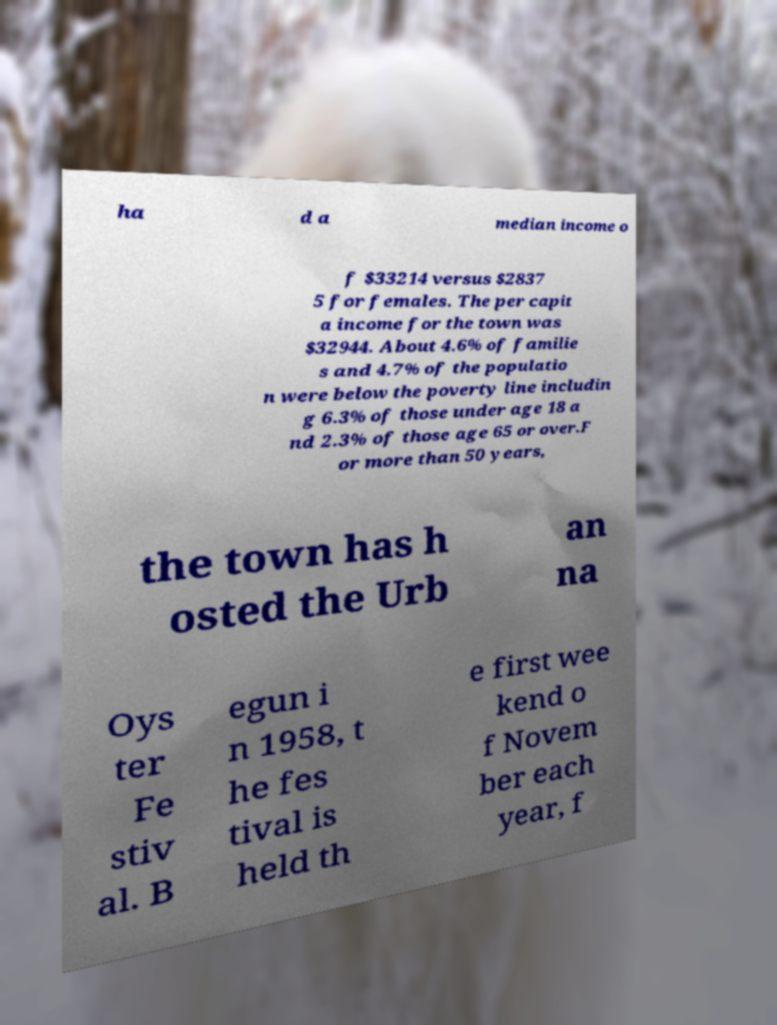There's text embedded in this image that I need extracted. Can you transcribe it verbatim? ha d a median income o f $33214 versus $2837 5 for females. The per capit a income for the town was $32944. About 4.6% of familie s and 4.7% of the populatio n were below the poverty line includin g 6.3% of those under age 18 a nd 2.3% of those age 65 or over.F or more than 50 years, the town has h osted the Urb an na Oys ter Fe stiv al. B egun i n 1958, t he fes tival is held th e first wee kend o f Novem ber each year, f 